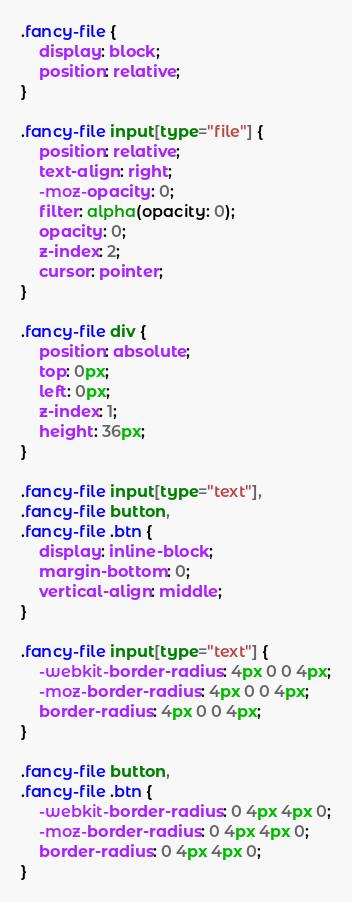Convert code to text. <code><loc_0><loc_0><loc_500><loc_500><_CSS_>.fancy-file {
    display: block;
    position: relative;
}

.fancy-file input[type="file"] {
    position: relative;
    text-align: right;
    -moz-opacity: 0;
    filter: alpha(opacity: 0);
    opacity: 0;
    z-index: 2;
    cursor: pointer;
}

.fancy-file div {
    position: absolute;
    top: 0px;
    left: 0px;
    z-index: 1;
    height: 36px;
}

.fancy-file input[type="text"],
.fancy-file button,
.fancy-file .btn {
    display: inline-block;
    margin-bottom: 0;
    vertical-align: middle;
}

.fancy-file input[type="text"] {
    -webkit-border-radius: 4px 0 0 4px;
    -moz-border-radius: 4px 0 0 4px;
    border-radius: 4px 0 0 4px;
}

.fancy-file button,
.fancy-file .btn {
    -webkit-border-radius: 0 4px 4px 0;
    -moz-border-radius: 0 4px 4px 0;
    border-radius: 0 4px 4px 0;
}
</code> 